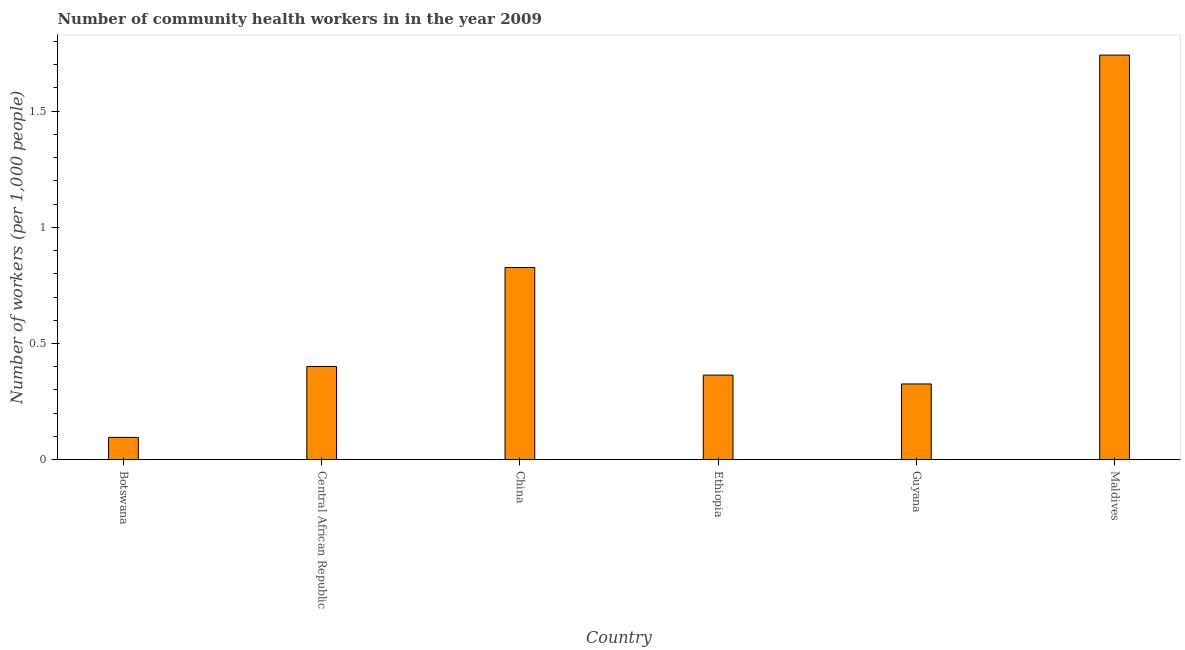Does the graph contain any zero values?
Offer a very short reply. No. Does the graph contain grids?
Provide a short and direct response. No. What is the title of the graph?
Make the answer very short. Number of community health workers in in the year 2009. What is the label or title of the X-axis?
Keep it short and to the point. Country. What is the label or title of the Y-axis?
Give a very brief answer. Number of workers (per 1,0 people). What is the number of community health workers in Central African Republic?
Keep it short and to the point. 0.4. Across all countries, what is the maximum number of community health workers?
Your response must be concise. 1.74. Across all countries, what is the minimum number of community health workers?
Make the answer very short. 0.1. In which country was the number of community health workers maximum?
Provide a short and direct response. Maldives. In which country was the number of community health workers minimum?
Make the answer very short. Botswana. What is the sum of the number of community health workers?
Your answer should be very brief. 3.76. What is the difference between the number of community health workers in Central African Republic and Ethiopia?
Offer a terse response. 0.04. What is the average number of community health workers per country?
Make the answer very short. 0.63. What is the median number of community health workers?
Keep it short and to the point. 0.38. What is the ratio of the number of community health workers in China to that in Maldives?
Keep it short and to the point. 0.47. Is the number of community health workers in Botswana less than that in Ethiopia?
Give a very brief answer. Yes. Is the difference between the number of community health workers in Central African Republic and China greater than the difference between any two countries?
Ensure brevity in your answer.  No. What is the difference between the highest and the second highest number of community health workers?
Your response must be concise. 0.91. Is the sum of the number of community health workers in Ethiopia and Maldives greater than the maximum number of community health workers across all countries?
Make the answer very short. Yes. What is the difference between the highest and the lowest number of community health workers?
Give a very brief answer. 1.65. In how many countries, is the number of community health workers greater than the average number of community health workers taken over all countries?
Offer a very short reply. 2. Are the values on the major ticks of Y-axis written in scientific E-notation?
Provide a succinct answer. No. What is the Number of workers (per 1,000 people) of Botswana?
Keep it short and to the point. 0.1. What is the Number of workers (per 1,000 people) in Central African Republic?
Keep it short and to the point. 0.4. What is the Number of workers (per 1,000 people) in China?
Provide a short and direct response. 0.83. What is the Number of workers (per 1,000 people) in Ethiopia?
Keep it short and to the point. 0.36. What is the Number of workers (per 1,000 people) in Guyana?
Your answer should be very brief. 0.33. What is the Number of workers (per 1,000 people) in Maldives?
Give a very brief answer. 1.74. What is the difference between the Number of workers (per 1,000 people) in Botswana and Central African Republic?
Your answer should be compact. -0.3. What is the difference between the Number of workers (per 1,000 people) in Botswana and China?
Your response must be concise. -0.73. What is the difference between the Number of workers (per 1,000 people) in Botswana and Ethiopia?
Your response must be concise. -0.27. What is the difference between the Number of workers (per 1,000 people) in Botswana and Guyana?
Offer a terse response. -0.23. What is the difference between the Number of workers (per 1,000 people) in Botswana and Maldives?
Make the answer very short. -1.65. What is the difference between the Number of workers (per 1,000 people) in Central African Republic and China?
Provide a short and direct response. -0.43. What is the difference between the Number of workers (per 1,000 people) in Central African Republic and Ethiopia?
Make the answer very short. 0.04. What is the difference between the Number of workers (per 1,000 people) in Central African Republic and Guyana?
Make the answer very short. 0.07. What is the difference between the Number of workers (per 1,000 people) in Central African Republic and Maldives?
Your answer should be compact. -1.34. What is the difference between the Number of workers (per 1,000 people) in China and Ethiopia?
Your response must be concise. 0.46. What is the difference between the Number of workers (per 1,000 people) in China and Guyana?
Offer a very short reply. 0.5. What is the difference between the Number of workers (per 1,000 people) in China and Maldives?
Provide a short and direct response. -0.91. What is the difference between the Number of workers (per 1,000 people) in Ethiopia and Guyana?
Provide a succinct answer. 0.04. What is the difference between the Number of workers (per 1,000 people) in Ethiopia and Maldives?
Keep it short and to the point. -1.38. What is the difference between the Number of workers (per 1,000 people) in Guyana and Maldives?
Offer a terse response. -1.42. What is the ratio of the Number of workers (per 1,000 people) in Botswana to that in Central African Republic?
Your answer should be very brief. 0.24. What is the ratio of the Number of workers (per 1,000 people) in Botswana to that in China?
Your answer should be compact. 0.12. What is the ratio of the Number of workers (per 1,000 people) in Botswana to that in Ethiopia?
Your answer should be very brief. 0.26. What is the ratio of the Number of workers (per 1,000 people) in Botswana to that in Guyana?
Provide a short and direct response. 0.29. What is the ratio of the Number of workers (per 1,000 people) in Botswana to that in Maldives?
Your response must be concise. 0.06. What is the ratio of the Number of workers (per 1,000 people) in Central African Republic to that in China?
Offer a terse response. 0.48. What is the ratio of the Number of workers (per 1,000 people) in Central African Republic to that in Ethiopia?
Your answer should be compact. 1.1. What is the ratio of the Number of workers (per 1,000 people) in Central African Republic to that in Guyana?
Provide a succinct answer. 1.23. What is the ratio of the Number of workers (per 1,000 people) in Central African Republic to that in Maldives?
Provide a short and direct response. 0.23. What is the ratio of the Number of workers (per 1,000 people) in China to that in Ethiopia?
Provide a succinct answer. 2.27. What is the ratio of the Number of workers (per 1,000 people) in China to that in Guyana?
Offer a very short reply. 2.54. What is the ratio of the Number of workers (per 1,000 people) in China to that in Maldives?
Your response must be concise. 0.47. What is the ratio of the Number of workers (per 1,000 people) in Ethiopia to that in Guyana?
Keep it short and to the point. 1.12. What is the ratio of the Number of workers (per 1,000 people) in Ethiopia to that in Maldives?
Ensure brevity in your answer.  0.21. What is the ratio of the Number of workers (per 1,000 people) in Guyana to that in Maldives?
Your response must be concise. 0.19. 